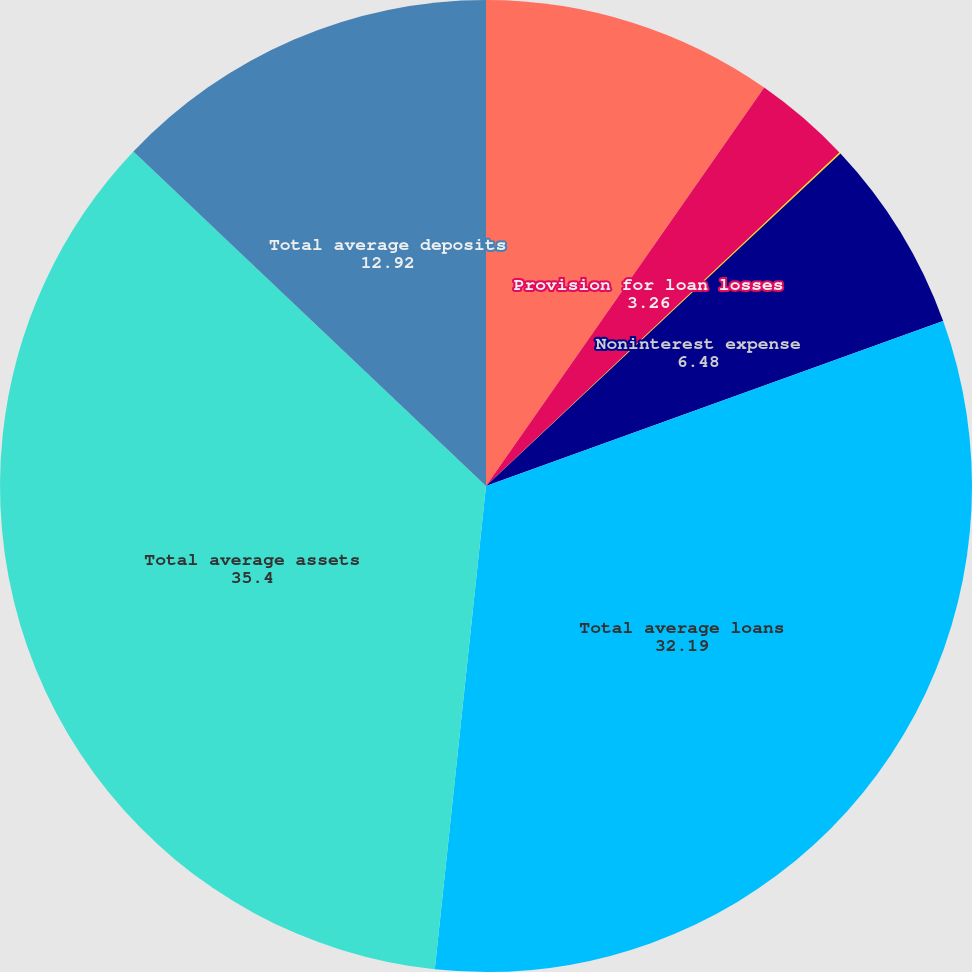Convert chart to OTSL. <chart><loc_0><loc_0><loc_500><loc_500><pie_chart><fcel>Net interest income<fcel>Provision for loan losses<fcel>Noninterest income<fcel>Noninterest expense<fcel>Total average loans<fcel>Total average assets<fcel>Total average deposits<nl><fcel>9.7%<fcel>3.26%<fcel>0.05%<fcel>6.48%<fcel>32.19%<fcel>35.4%<fcel>12.92%<nl></chart> 